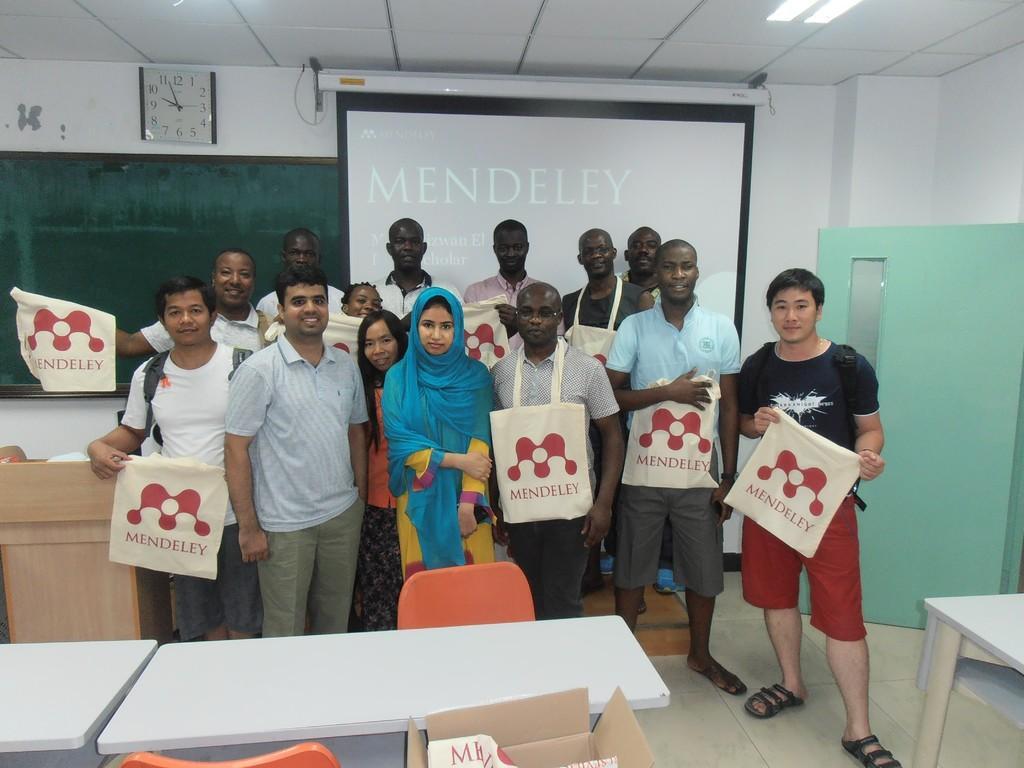Please provide a concise description of this image. In the picture I can see some group of persons standing and some are holding cover bags, in the foreground of the image there are some tables and chairs and in the background of the picture there is projector screen, board and wall clock which is attached to the wall. 